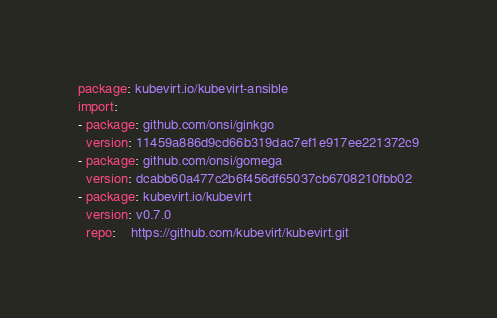<code> <loc_0><loc_0><loc_500><loc_500><_YAML_>package: kubevirt.io/kubevirt-ansible
import:
- package: github.com/onsi/ginkgo
  version: 11459a886d9cd66b319dac7ef1e917ee221372c9
- package: github.com/onsi/gomega
  version: dcabb60a477c2b6f456df65037cb6708210fbb02
- package: kubevirt.io/kubevirt
  version: v0.7.0
  repo:    https://github.com/kubevirt/kubevirt.git
</code> 